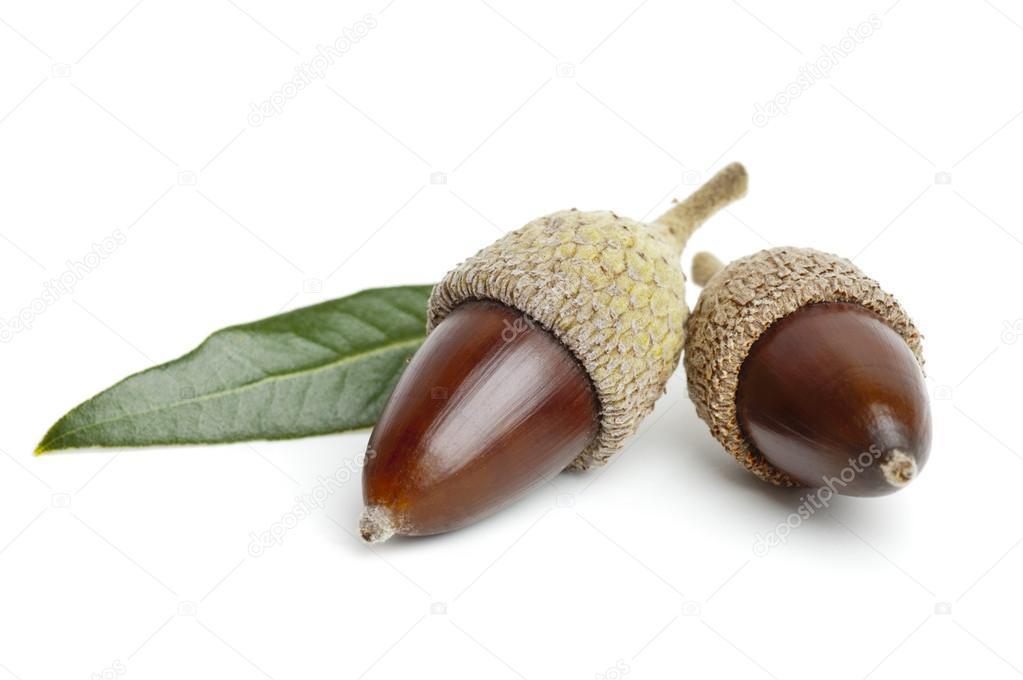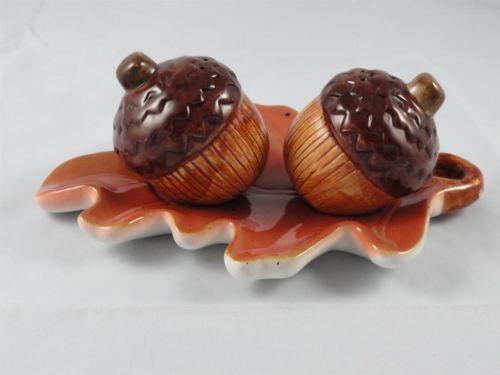The first image is the image on the left, the second image is the image on the right. For the images displayed, is the sentence "At least one image contains two real-looking side-by-side brown acorns with caps on." factually correct? Answer yes or no. Yes. The first image is the image on the left, the second image is the image on the right. For the images shown, is this caption "The left and right image contains a total of five arons." true? Answer yes or no. No. 